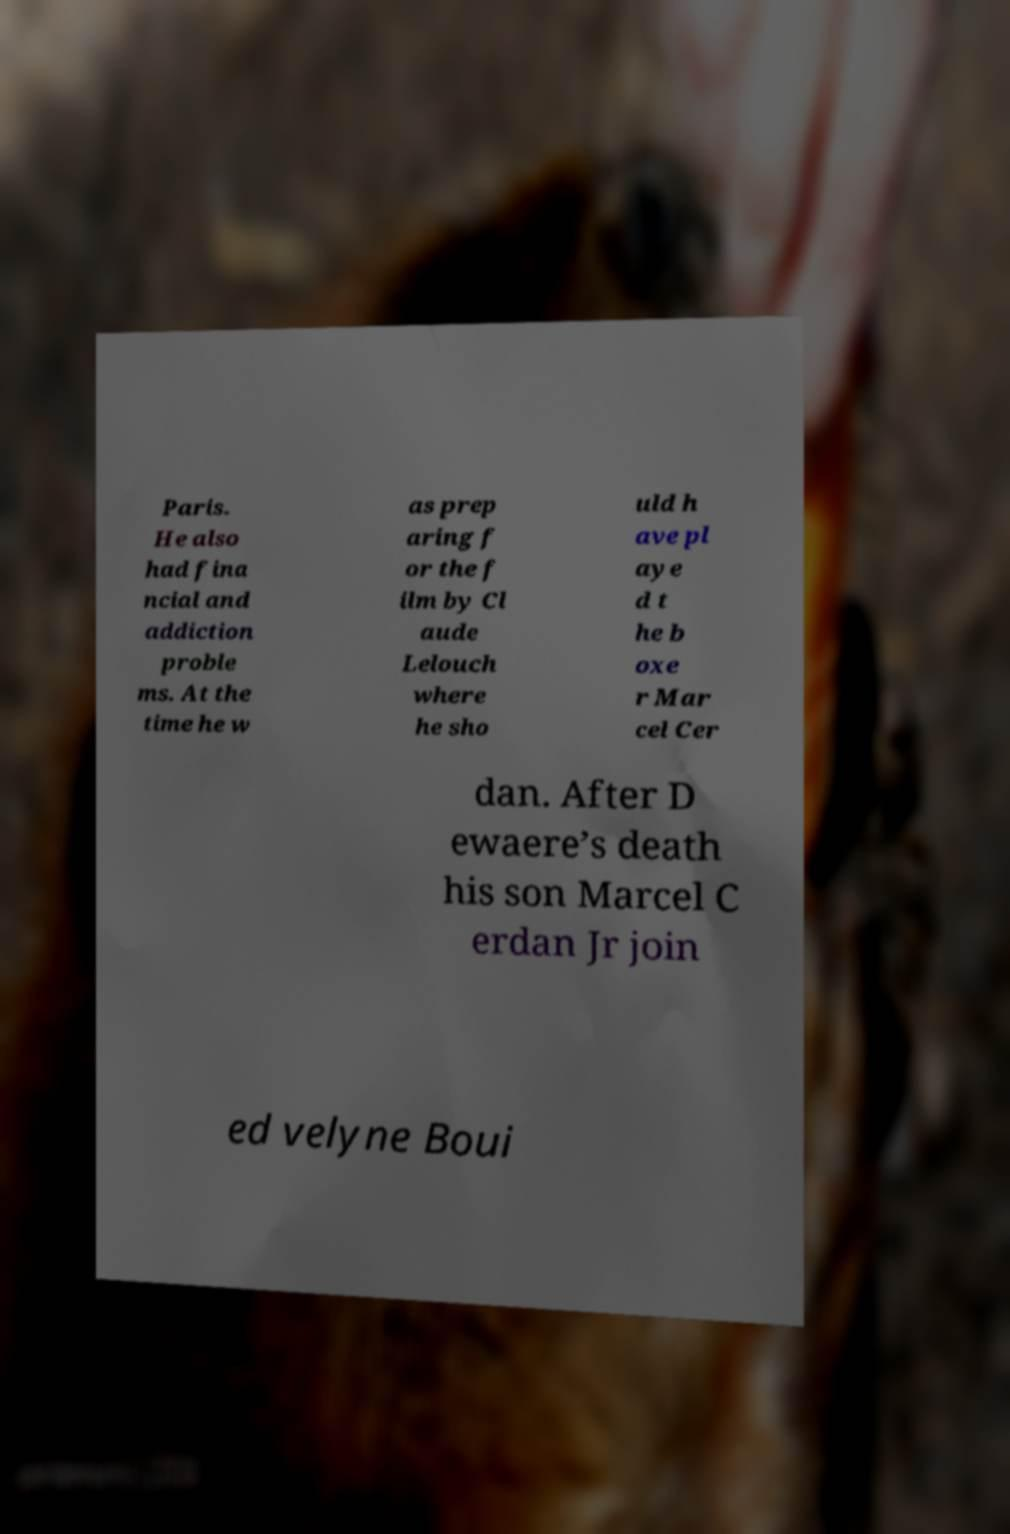Please identify and transcribe the text found in this image. Paris. He also had fina ncial and addiction proble ms. At the time he w as prep aring f or the f ilm by Cl aude Lelouch where he sho uld h ave pl aye d t he b oxe r Mar cel Cer dan. After D ewaere’s death his son Marcel C erdan Jr join ed velyne Boui 